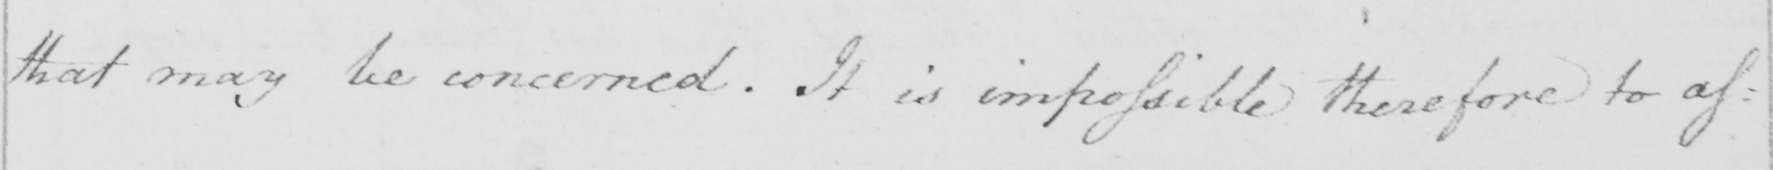Please provide the text content of this handwritten line. that may be concerned . It is impossible therefore to as : 